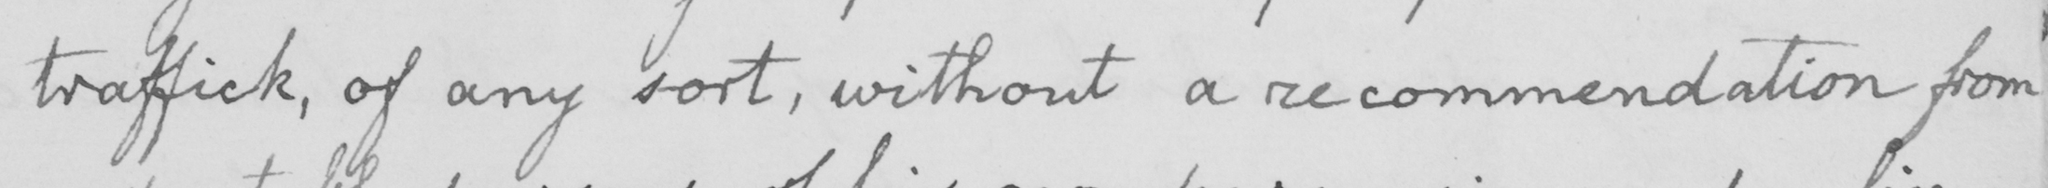Can you tell me what this handwritten text says? traffic , of any sort , without a recommendation from 